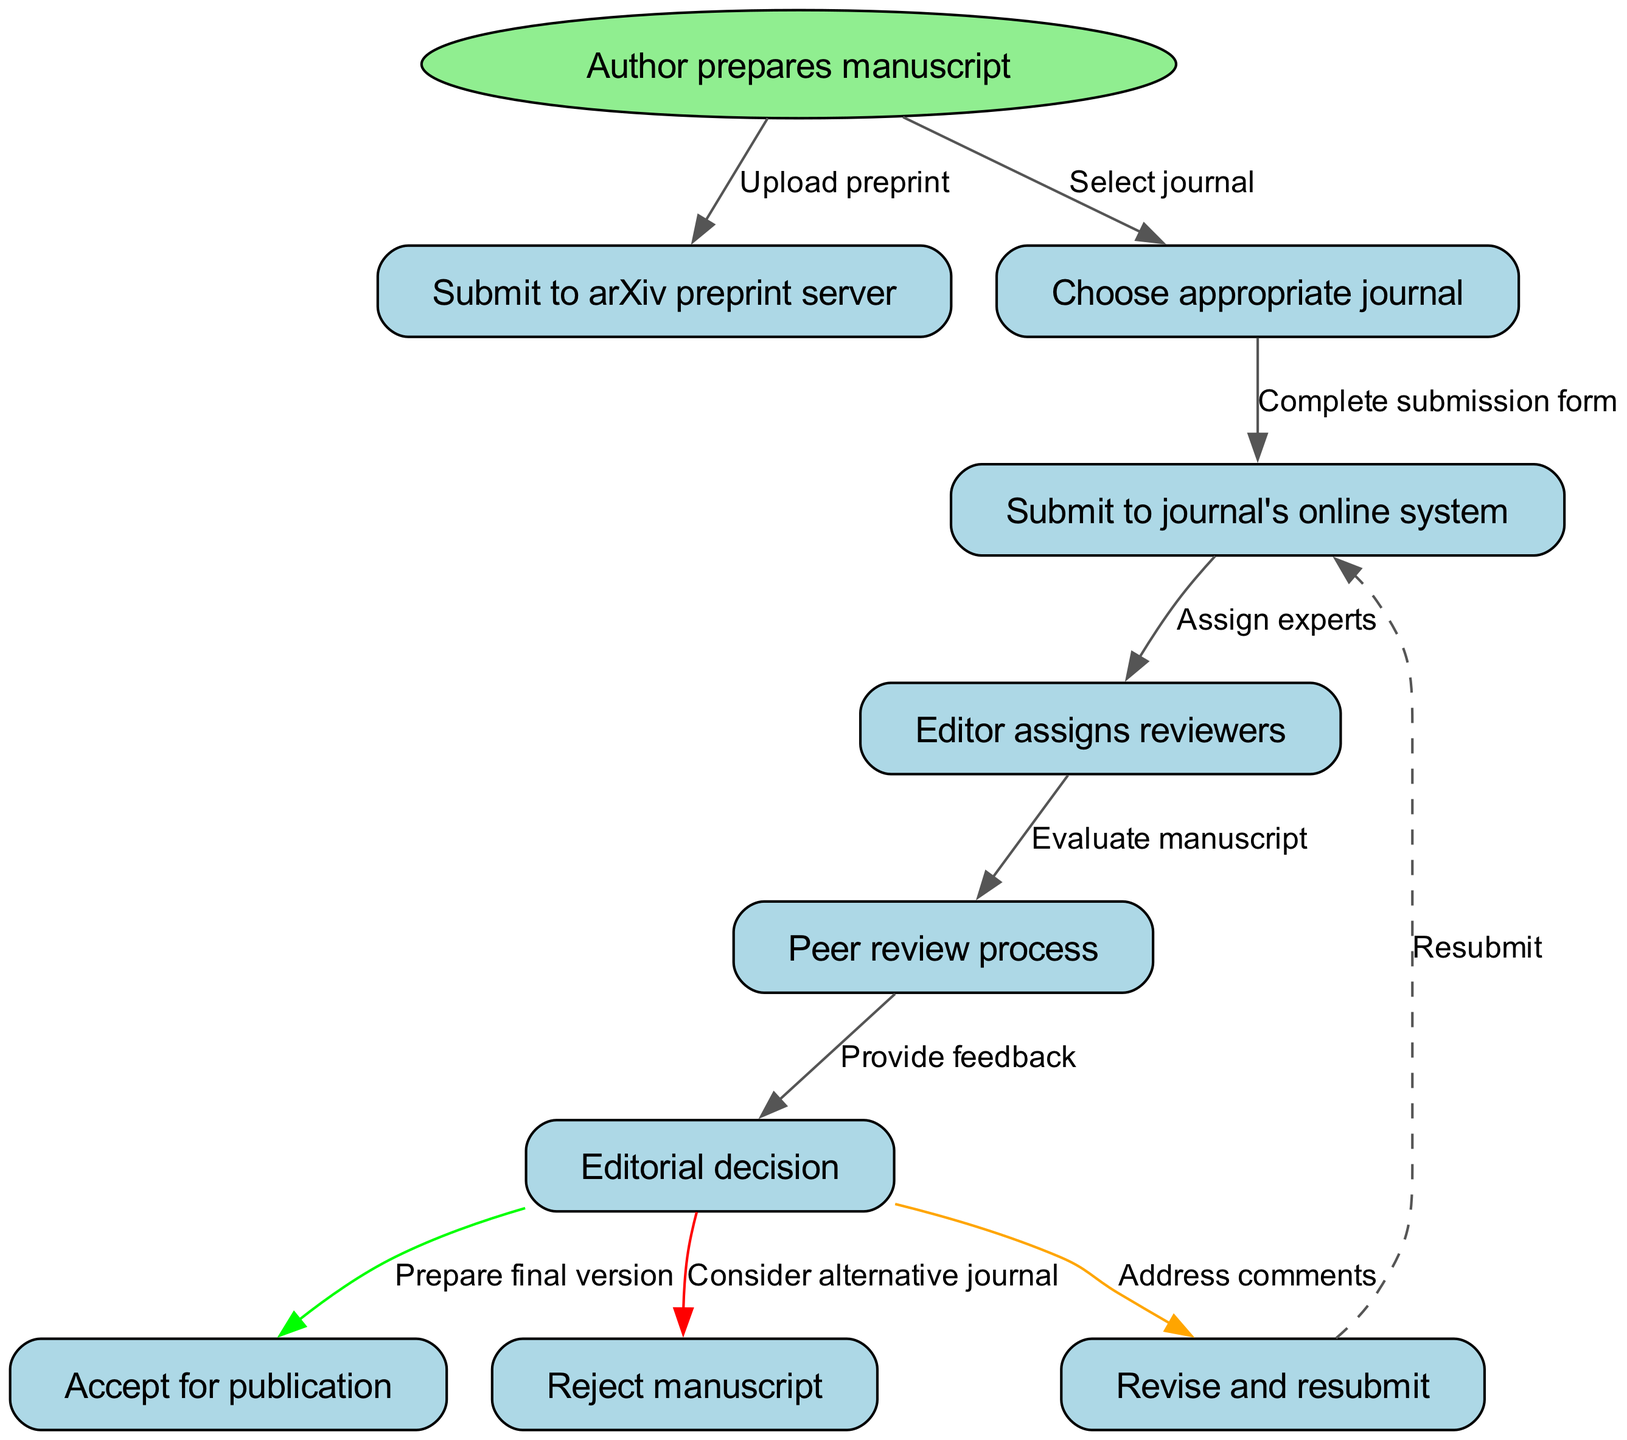What is the first action an author takes? The diagram indicates that the first action is "Author prepares manuscript." This is the starting point of the flow chart.
Answer: Author prepares manuscript How many total nodes are present in this diagram? The diagram lists a total of 9 nodes, including the start node and the 8 subsequent actions.
Answer: 9 What happens after "Submit to arXiv preprint server"? According to the flow, after submitting to the arXiv preprint server, the next step is to "Choose appropriate journal." This indicates a transition to selecting the right publication venue.
Answer: Choose appropriate journal Which node has the action "Editorial decision"? The node representing the action "Editorial decision" is labeled 'n5' in the flow chart. This is a central point in the review process where the editor decides the fate of the submission.
Answer: n5 What is the consequence of the "Editorial decision"? After the "Editorial decision" node, the flow offers three possible outcomes: "Revise and resubmit," "Accept for publication," or "Reject manuscript." This represents the three pathways an author may take based on the editorial feedback.
Answer: Revise and resubmit, Accept for publication, Reject manuscript If the manuscript is rejected, what should the author do next? If the manuscript is rejected, the next recommended action is to "Consider alternative journal" as indicated by the connection from the "Reject manuscript" node. This guides the author to seek other publishing opportunities.
Answer: Consider alternative journal What is the purpose of the edge labeled "Assign experts"? The edge labeled "Assign experts" connects the "Editor assigns reviewers" node, indicating that this step is part of the review process where the editor selects appropriate reviewers for the manuscript. This is critical for ensuring the quality of the peer review.
Answer: Assign experts What action directly follows "Peer review process"? The action that directly follows "Peer review process" is "Editorial decision," indicating that after reviews are completed, the editor assesses the feedback and makes a decision on the paper’s status.
Answer: Editorial decision What is the significance of the dashed line leading back to "Submit to journal's online system"? The dashed line indicates a potential loop, suggesting that if revisions are required after the editorial decision, the author needs to "Revise and resubmit," which brings them back to the submission stage for consideration again.
Answer: Revise and resubmit 